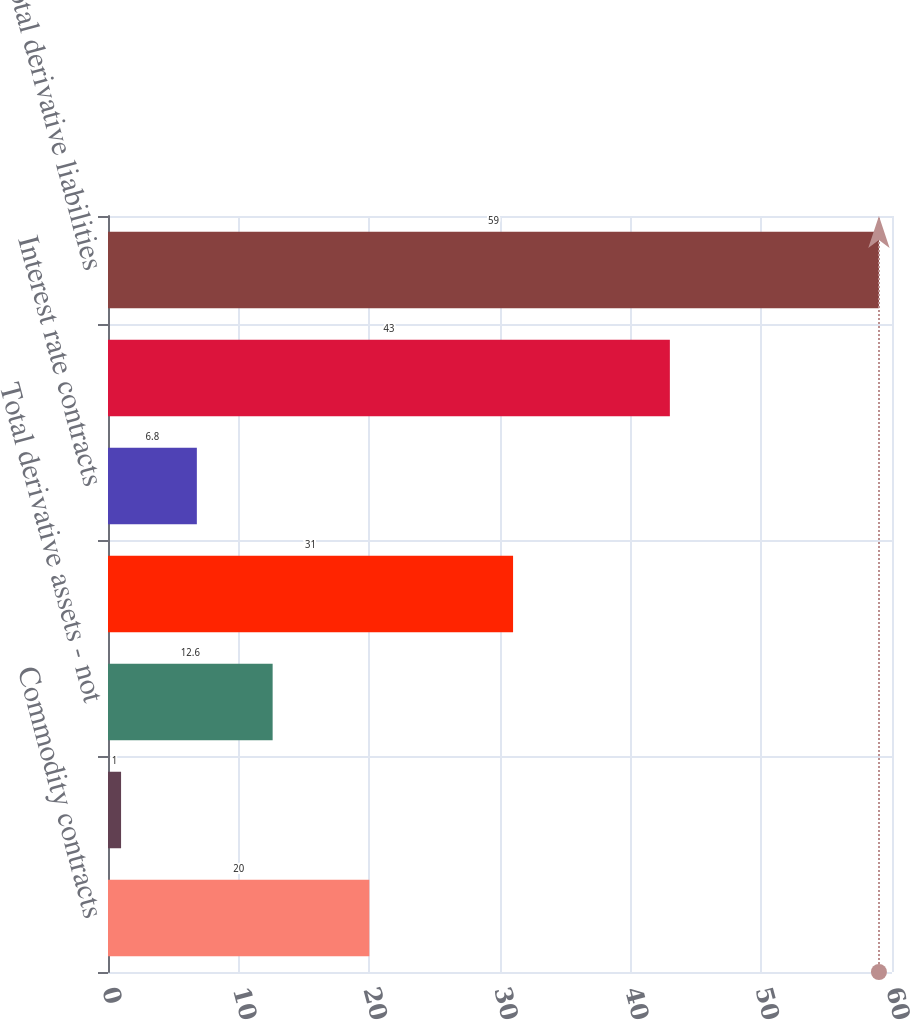<chart> <loc_0><loc_0><loc_500><loc_500><bar_chart><fcel>Commodity contracts<fcel>Foreign exchange contracts<fcel>Total derivative assets - not<fcel>Total derivative assets<fcel>Interest rate contracts<fcel>Total derivative liabilities -<fcel>Total derivative liabilities<nl><fcel>20<fcel>1<fcel>12.6<fcel>31<fcel>6.8<fcel>43<fcel>59<nl></chart> 